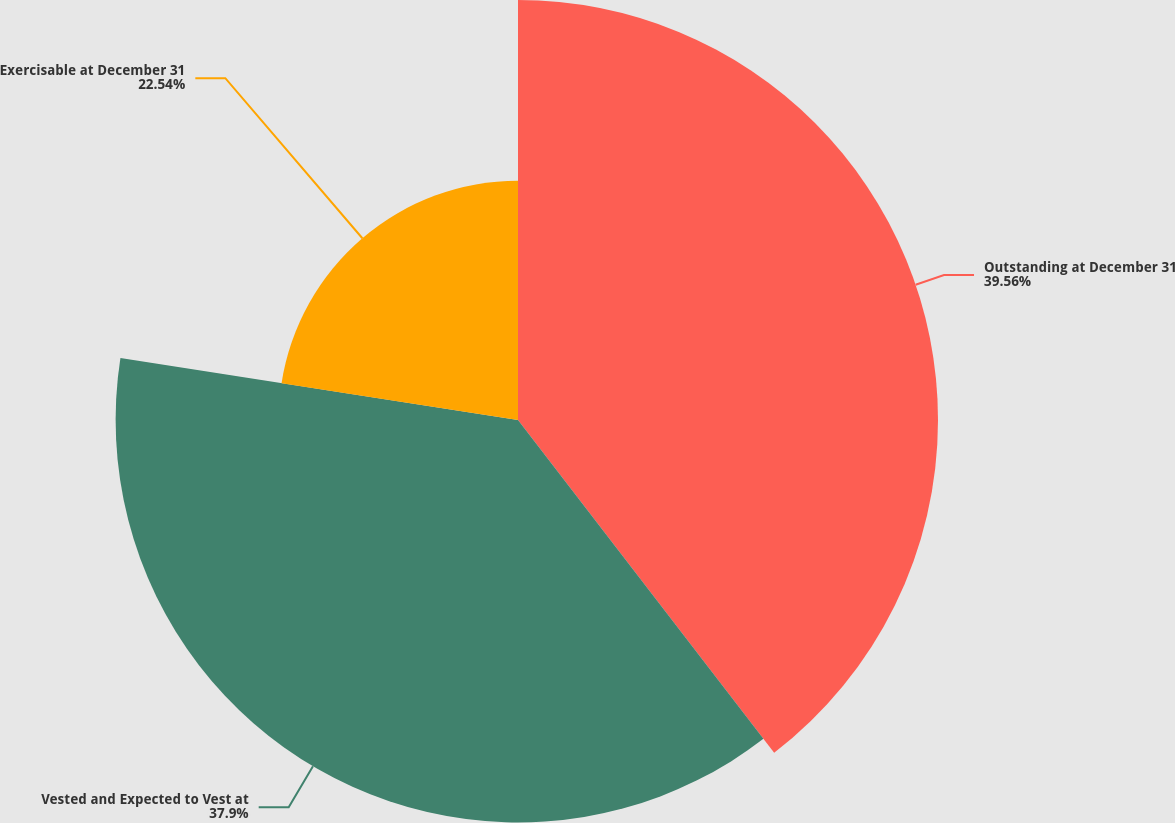<chart> <loc_0><loc_0><loc_500><loc_500><pie_chart><fcel>Outstanding at December 31<fcel>Vested and Expected to Vest at<fcel>Exercisable at December 31<nl><fcel>39.56%<fcel>37.9%<fcel>22.54%<nl></chart> 